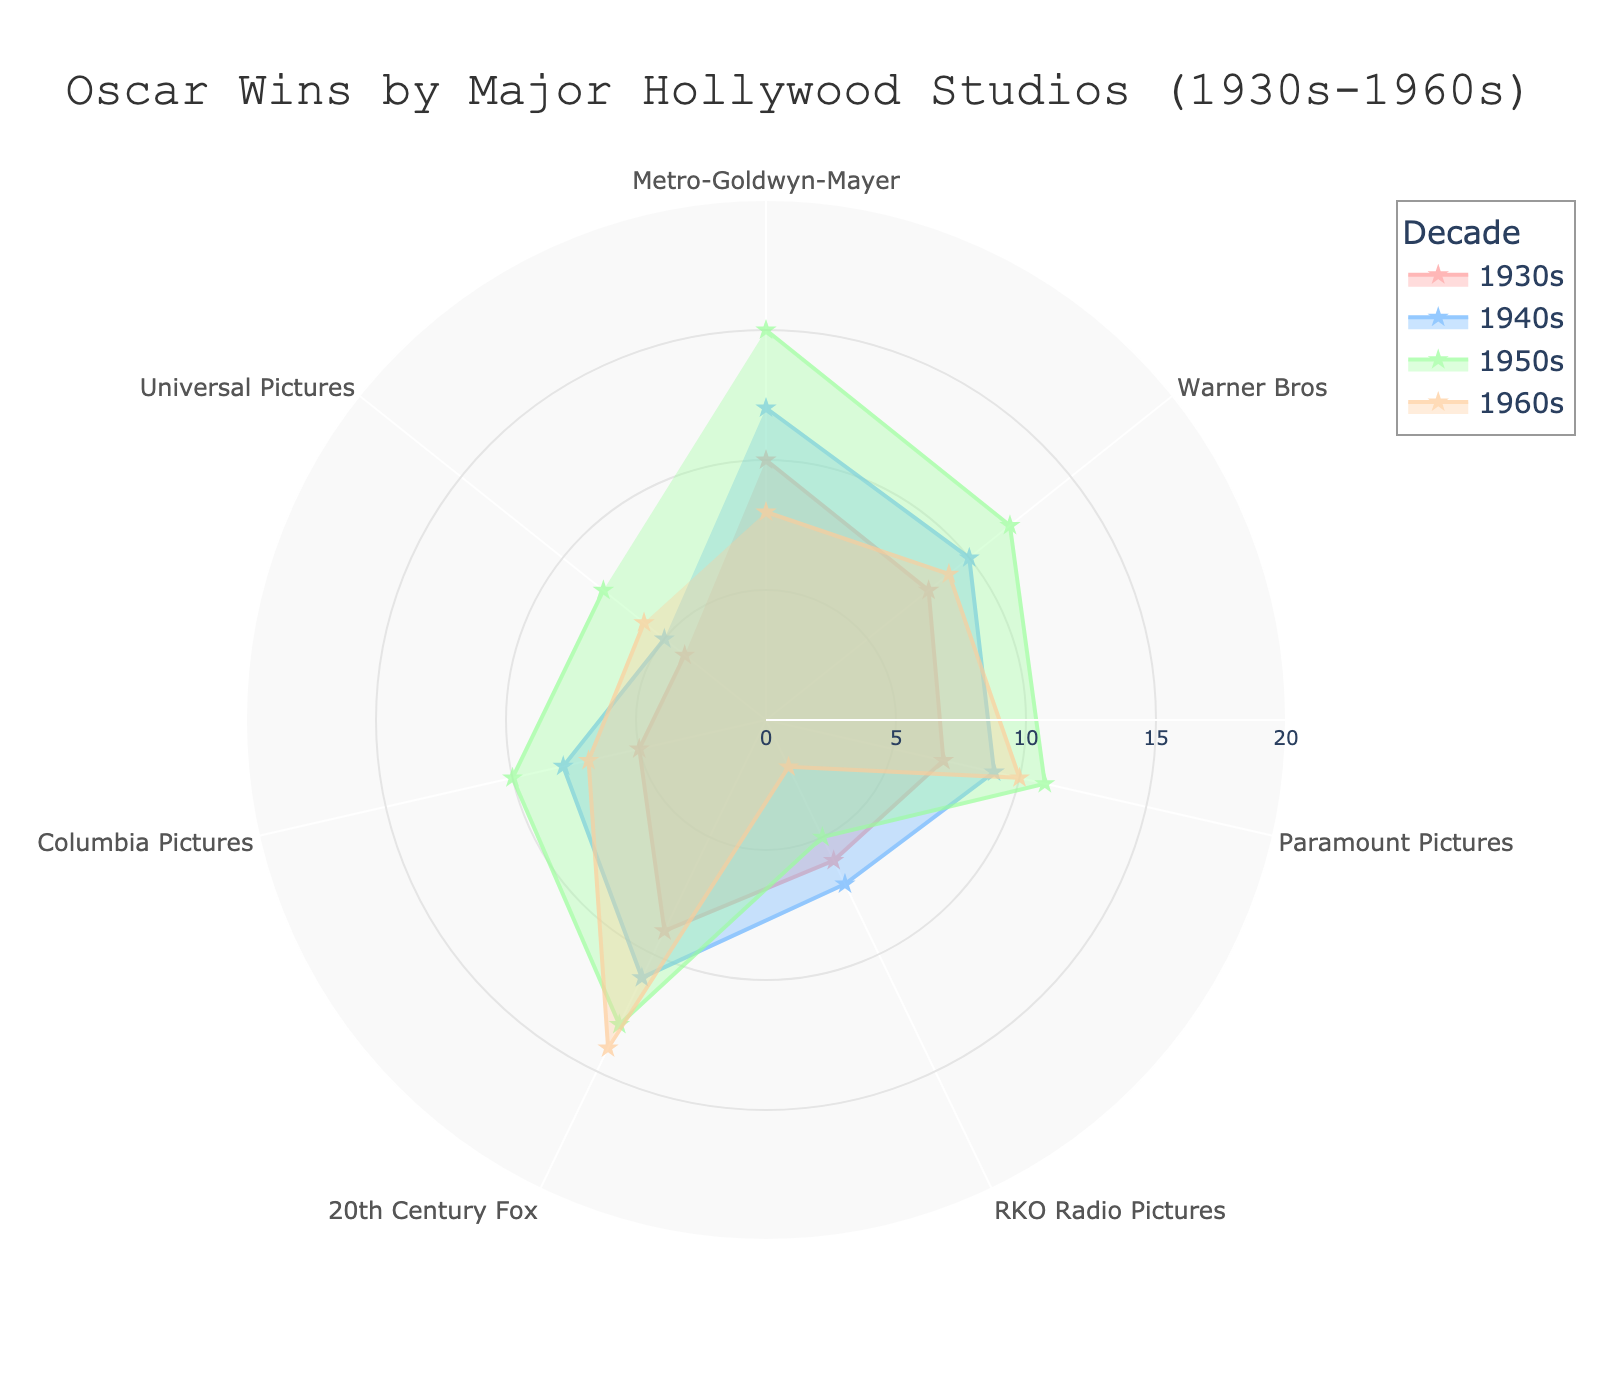What is the title of the chart? The title is placed at the top center of the chart. It reads "Oscar Wins by Major Hollywood Studios (1930s-1960s)".
Answer: Oscar Wins by Major Hollywood Studios (1930s-1960s) What is the radial axis range of the polar area chart? The radial axis range is from 0 to 20, as indicated by the radial axis ticks and their visibility in the chart.
Answer: 0 to 20 Which studio won the most Oscars in the 1950s? Look at the spread of the '1950s' trace. Metro-Goldwyn-Mayer has the highest radial point in the 1950s trace.
Answer: Metro-Goldwyn-Mayer Which studio has the lowest number of Oscar wins in the 1960s? By observing the '1960s' section, RKO Radio Pictures has the smallest radial point in the 1960s.
Answer: RKO Radio Pictures How does the number of Oscar wins for Warner Bros in the 1930s compare to the 1960s? Warner Bros has a radial point of 8 in the 1930s and 9 in the 1960s.
Answer: Higher in the 1960s Which two studios showed no change in the number of wins between any two consecutive decades? Identify studios whose radial points remain the same between two decades. Warner Bros (12 in 1950s, 12 in 1960s) and Paramount Pictures (11 in 1950s, 11 in 1960s).
Answer: Warner Bros, Paramount Pictures Add up the total Oscar wins for Metro-Goldwyn-Mayer in all decades. Add MGM’s Oscar wins: 10 (1930s) + 12 (1940s) + 15 (1950s) + 8 (1960s) = 45.
Answer: 45 Which studio had the steepest decline in Oscar wins from the 1950s to the 1960s? Compare declines between 1950s and 1960s for each studio. RKO Radio Pictures decreases from 5 to 2, the steepest drop of 3.
Answer: RKO Radio Pictures What is the average number of Oscar wins across all studios in the 1940s? Sum the Oscar wins in the 1940s for all studios and divide by the number of studios: (12 + 10 + 9 + 7 + 11 + 8 + 5) / 7 = 8.857.
Answer: 8.857 Among the studios, which had consistent increases in Oscar wins from the 1930s to the 1960s? Determine which studios have no declines in any decade. 20th Century Fox increased consistently: 9 (1930s) → 11 (1940s) → 13 (1950s) → 14 (1960s).
Answer: 20th Century Fox 